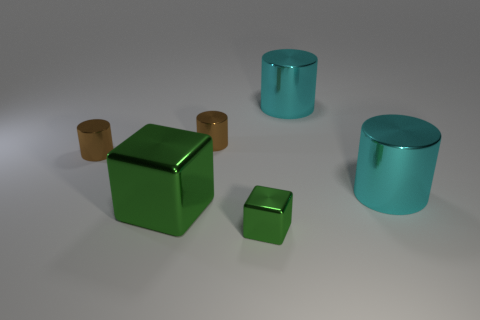What number of other objects are there of the same color as the small metallic cube?
Your response must be concise. 1. Do the small metallic cube and the big cube have the same color?
Make the answer very short. Yes. Does the large shiny cube have the same color as the cube on the right side of the large green metallic object?
Offer a very short reply. Yes. What is the material of the small object that is the same color as the large shiny cube?
Give a very brief answer. Metal. Is there a large shiny cube that has the same color as the tiny cube?
Your response must be concise. Yes. There is a small green thing that is in front of the large green shiny thing; is it the same shape as the big green thing?
Your answer should be very brief. Yes. How many tiny green objects are to the right of the tiny brown cylinder that is on the left side of the big green metal object?
Offer a very short reply. 1. Do the green block in front of the large shiny block and the big green block have the same material?
Make the answer very short. Yes. Does the green block behind the small block have the same material as the tiny block in front of the large green shiny object?
Offer a terse response. Yes. Are there more large green things behind the large green object than green metal things?
Your answer should be very brief. No. 